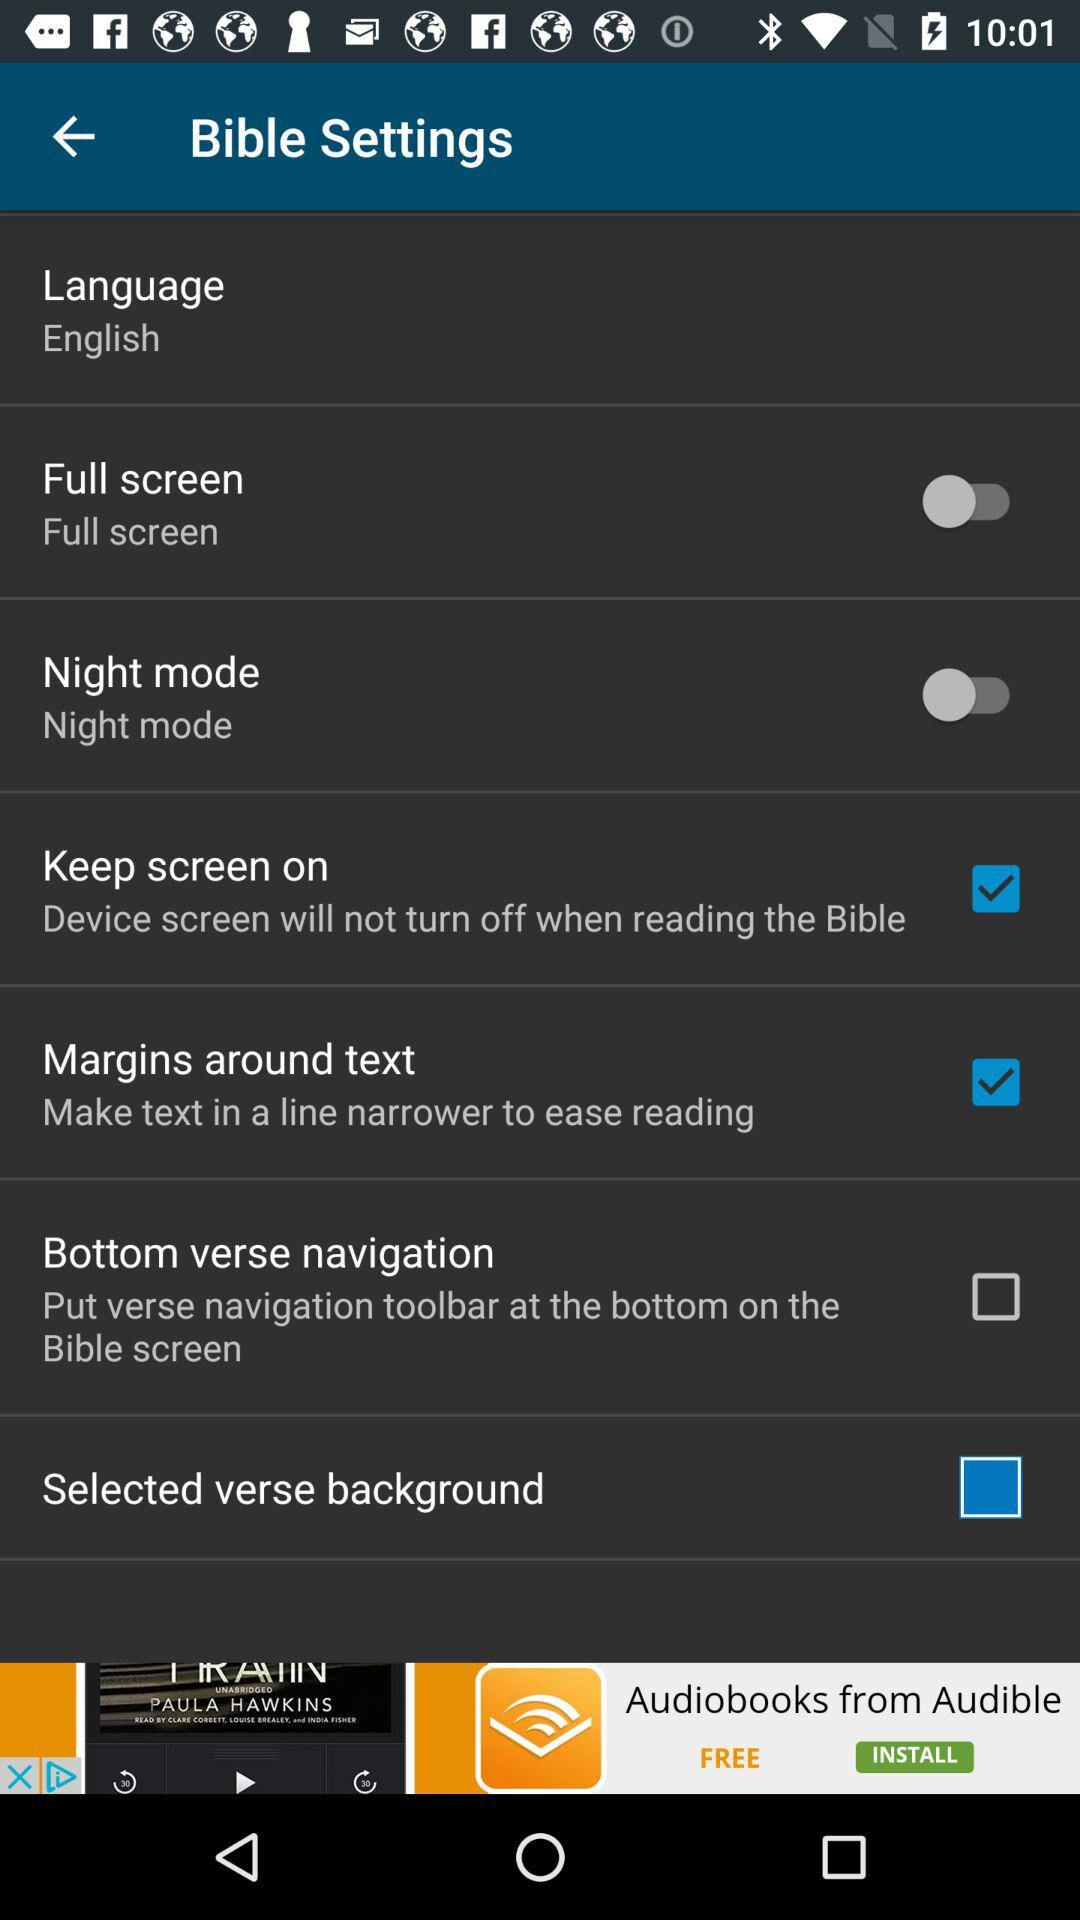What is the selected language? The selected language is English. 